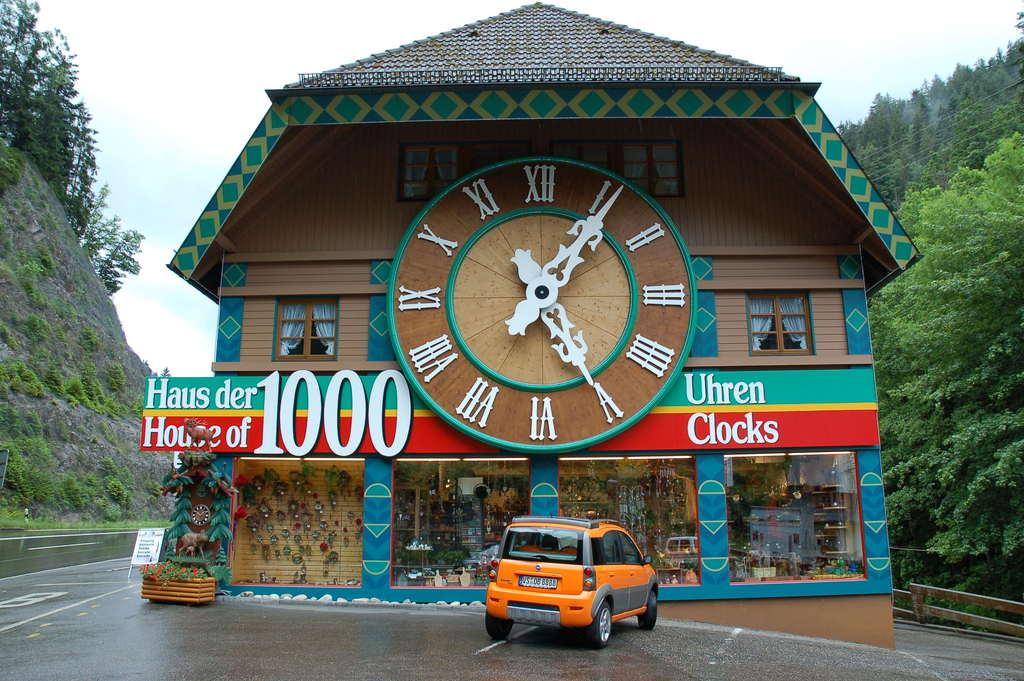Provide a one-sentence caption for the provided image. A building with a huge clock on it has the number 1000 on its sign. 